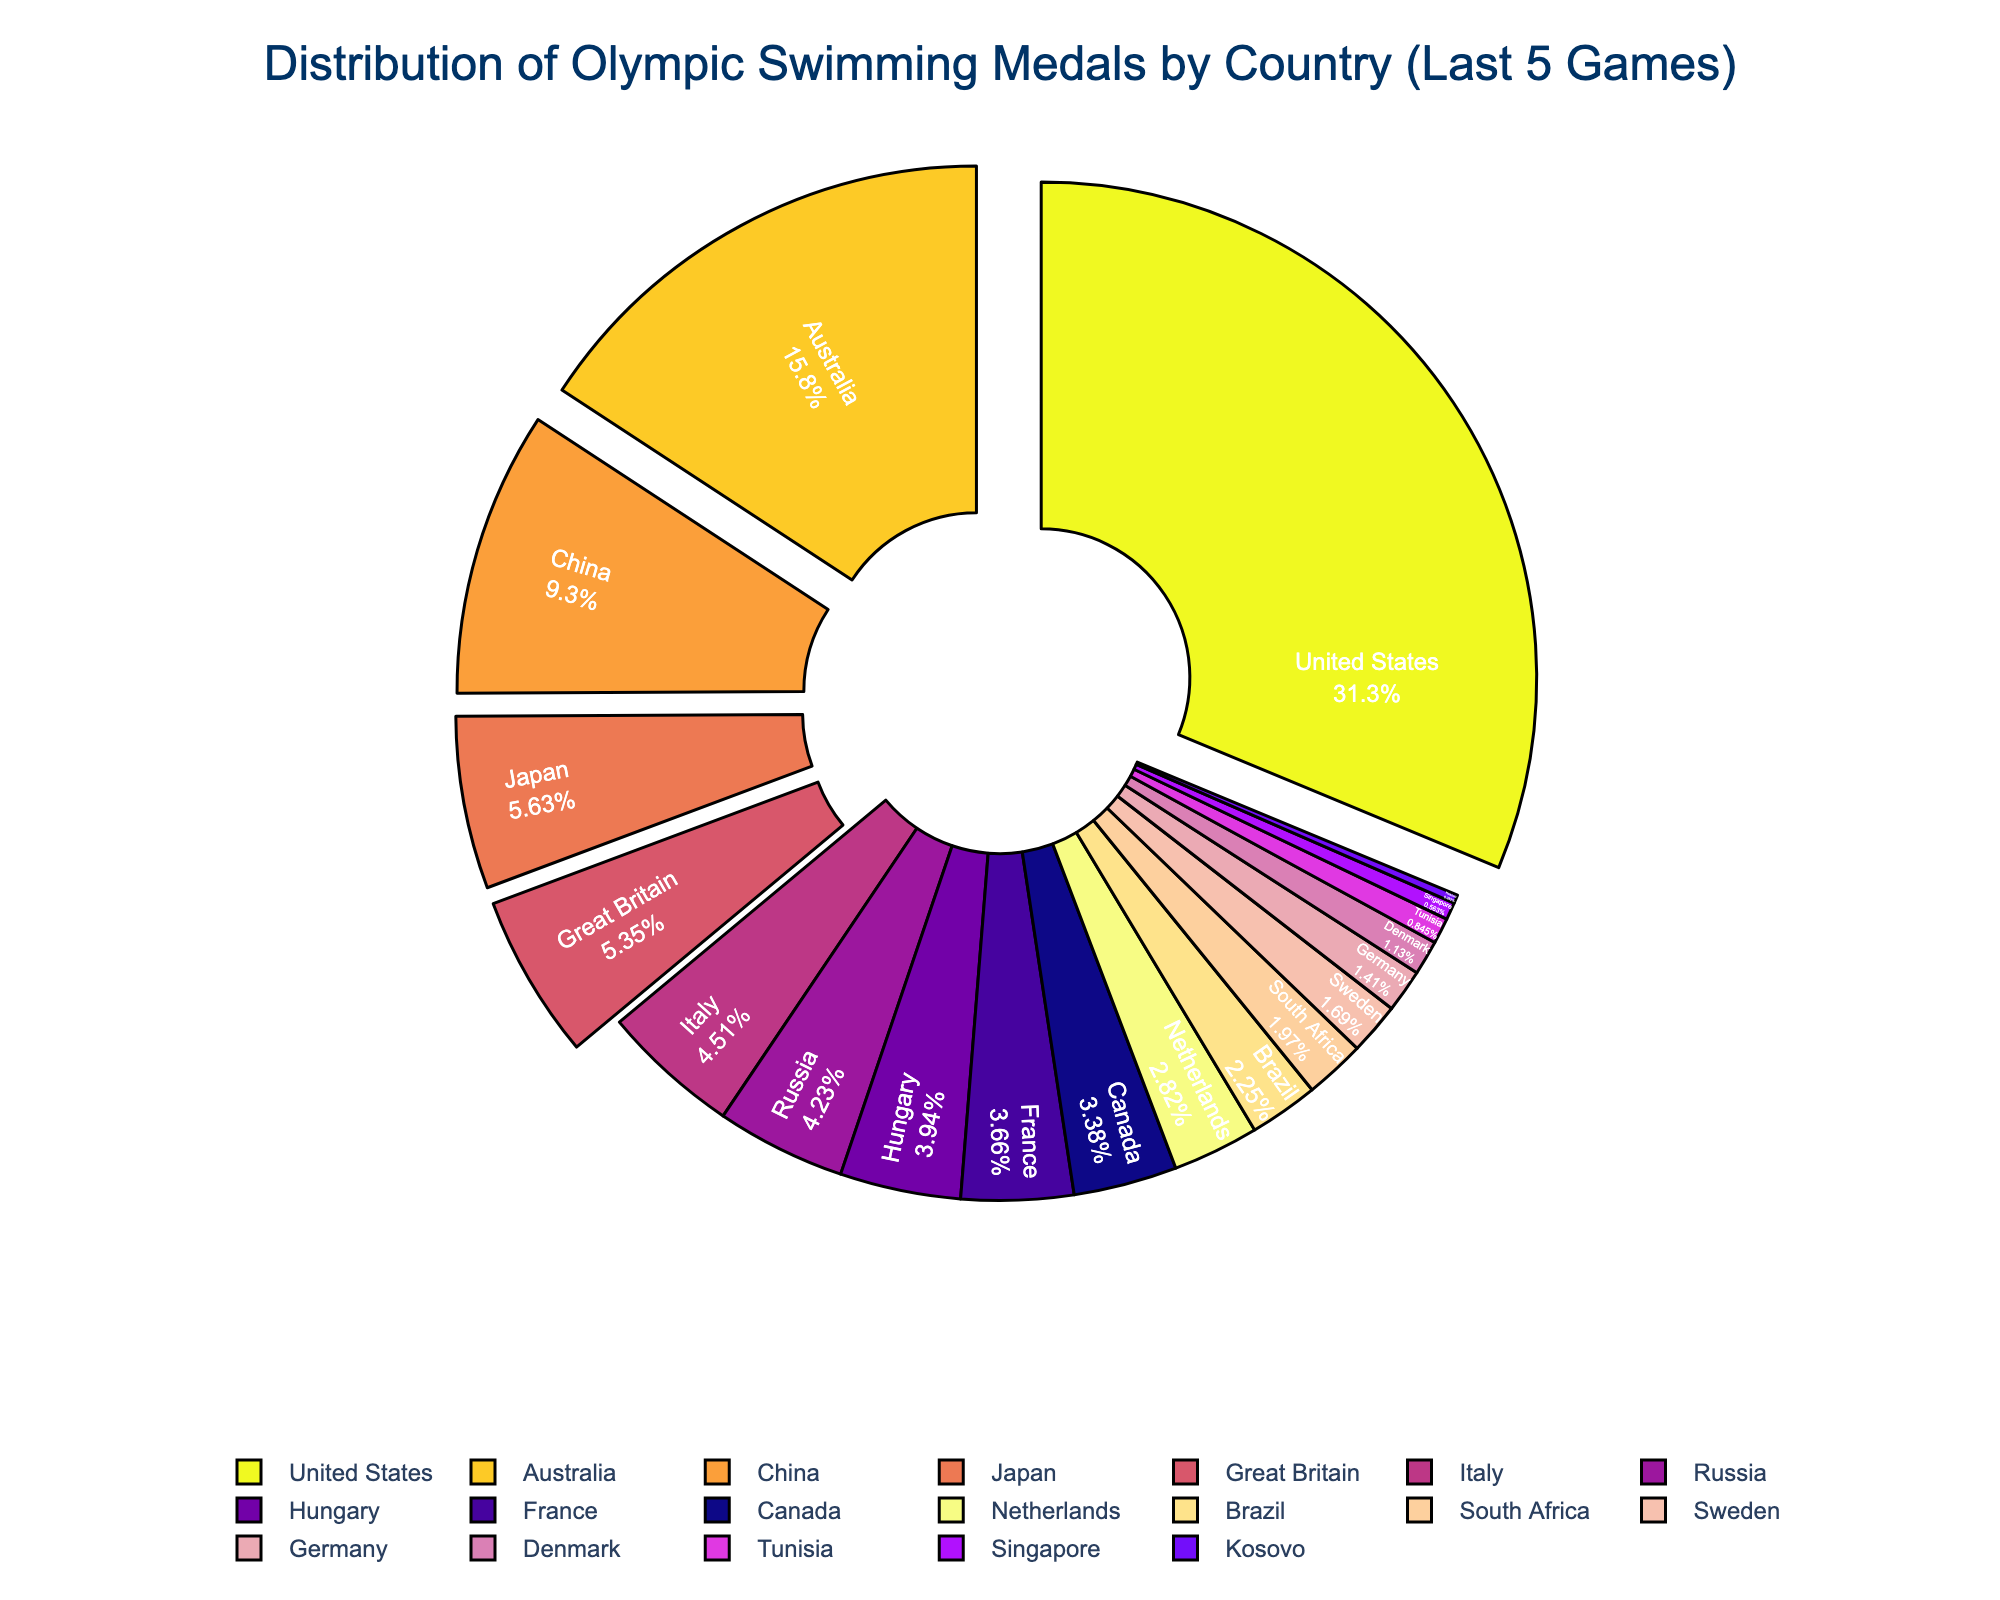Which country won the most Olympic swimming medals in the last 5 Games? The United States has the largest section in the pie chart and occupies the biggest portion of the circle.
Answer: United States Which country has the second-highest medal count? Australia has the second-largest section in the pie chart, directly following the United States.
Answer: Australia How many total medals did China and Japan win? China has 33 medals and Japan has 20 medals. Adding them together gives 33 + 20.
Answer: 53 Is the number of medals won by Great Britain less than or equal to those won by Australia? Great Britain has 19 medals, which is less than the 56 medals won by Australia.
Answer: Yes Which countries together account for more than half of all the medals? The United States and Australia dominate the pie chart and their combined medal count is 111 + 56 = 167. This is more than half of the total sum (111 + 56 + 33 + 20 + 19 + ...).
Answer: United States and Australia Rank the top three countries with the highest medal counts? The top three countries in the pie chart with the largest sections are the United States, Australia, and China.
Answer: United States, Australia, China Did any country win exactly 1 medal? The pie chart includes a small section labeled Kosovo with 1 medal.
Answer: Yes How many more medals did the United States win compared to Great Britain? The United States won 111 medals and Great Britain won 19 medals. The difference is 111 - 19.
Answer: 92 What is the combined medal count for the bottom three countries? The bottom three countries - Singapore (2), Kosovo (1), and Tunisia (3) - have a combined count of 2 + 1 + 3.
Answer: 6 Which country has a higher medal count, Russia or Italy? By looking at the pie chart, Russia has 15 medals whereas Italy has 16 medals.
Answer: Italy 